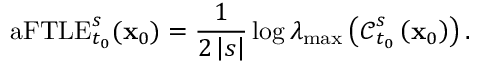Convert formula to latex. <formula><loc_0><loc_0><loc_500><loc_500>a F T L E _ { t _ { 0 } } ^ { s } ( x _ { 0 } ) = \frac { 1 } { 2 \left | s \right | } \log \lambda _ { \max } \left ( \mathcal { C } _ { t _ { 0 } } ^ { s } \left ( x _ { 0 } \right ) \right ) .</formula> 